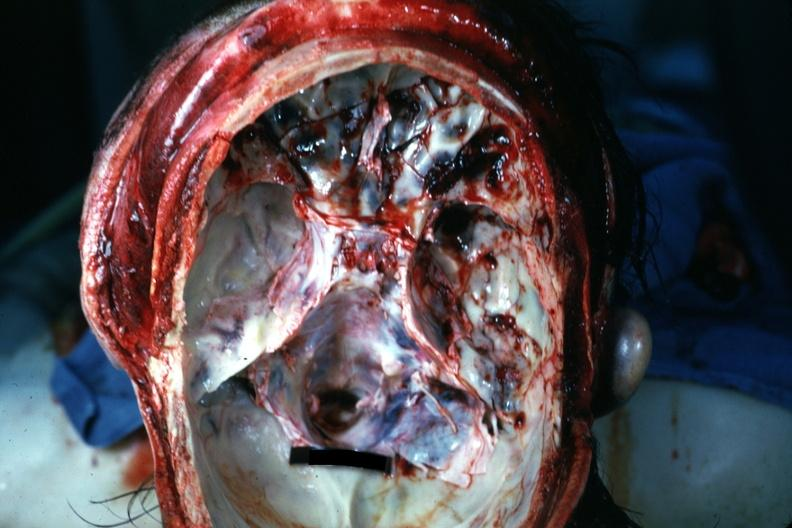does this image show opened cranial vault with many frontal and right temporal fossa fractures?
Answer the question using a single word or phrase. Yes 